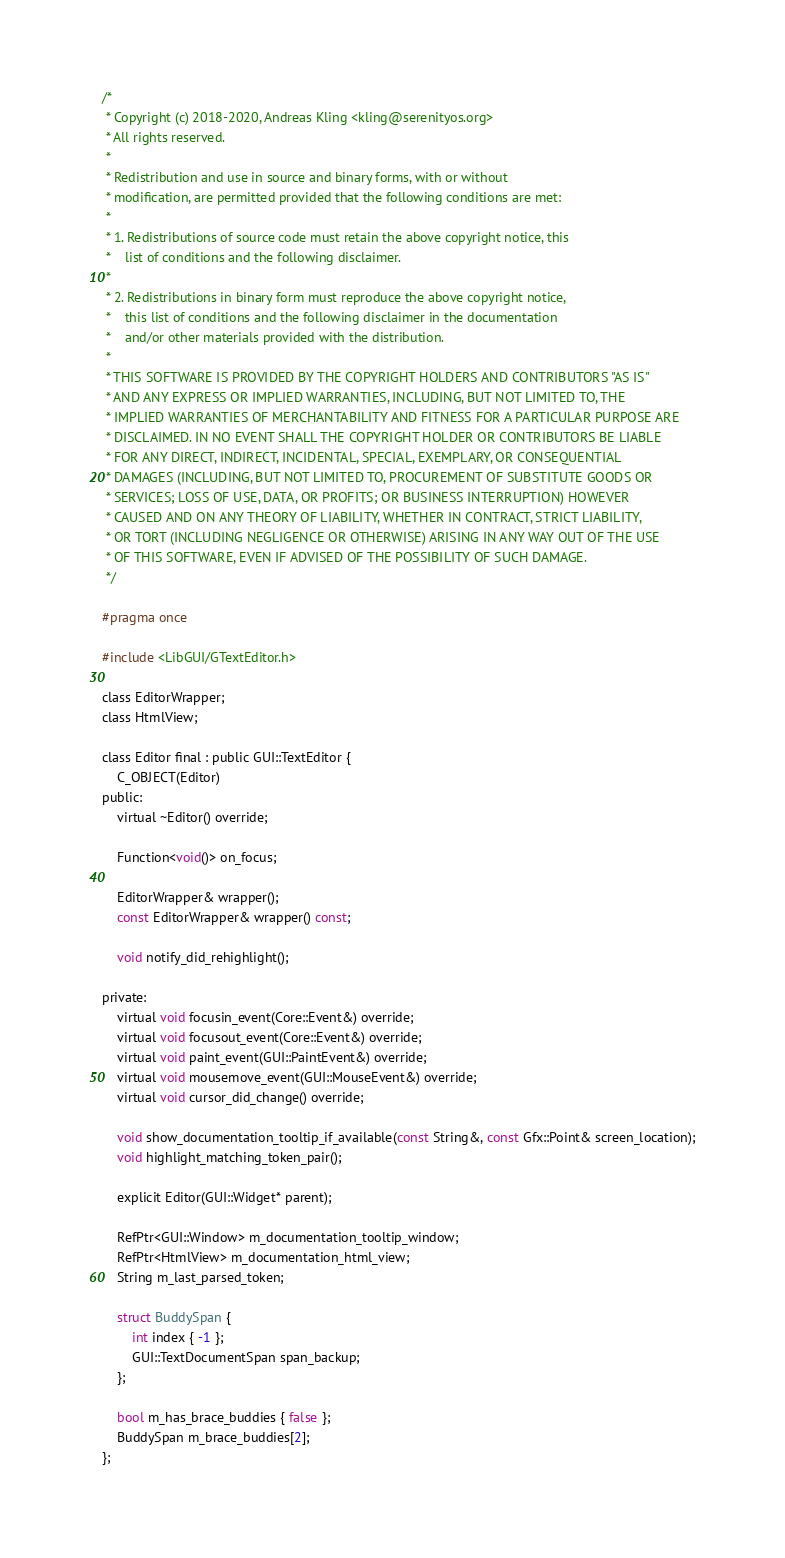Convert code to text. <code><loc_0><loc_0><loc_500><loc_500><_C_>/*
 * Copyright (c) 2018-2020, Andreas Kling <kling@serenityos.org>
 * All rights reserved.
 *
 * Redistribution and use in source and binary forms, with or without
 * modification, are permitted provided that the following conditions are met:
 *
 * 1. Redistributions of source code must retain the above copyright notice, this
 *    list of conditions and the following disclaimer.
 *
 * 2. Redistributions in binary form must reproduce the above copyright notice,
 *    this list of conditions and the following disclaimer in the documentation
 *    and/or other materials provided with the distribution.
 *
 * THIS SOFTWARE IS PROVIDED BY THE COPYRIGHT HOLDERS AND CONTRIBUTORS "AS IS"
 * AND ANY EXPRESS OR IMPLIED WARRANTIES, INCLUDING, BUT NOT LIMITED TO, THE
 * IMPLIED WARRANTIES OF MERCHANTABILITY AND FITNESS FOR A PARTICULAR PURPOSE ARE
 * DISCLAIMED. IN NO EVENT SHALL THE COPYRIGHT HOLDER OR CONTRIBUTORS BE LIABLE
 * FOR ANY DIRECT, INDIRECT, INCIDENTAL, SPECIAL, EXEMPLARY, OR CONSEQUENTIAL
 * DAMAGES (INCLUDING, BUT NOT LIMITED TO, PROCUREMENT OF SUBSTITUTE GOODS OR
 * SERVICES; LOSS OF USE, DATA, OR PROFITS; OR BUSINESS INTERRUPTION) HOWEVER
 * CAUSED AND ON ANY THEORY OF LIABILITY, WHETHER IN CONTRACT, STRICT LIABILITY,
 * OR TORT (INCLUDING NEGLIGENCE OR OTHERWISE) ARISING IN ANY WAY OUT OF THE USE
 * OF THIS SOFTWARE, EVEN IF ADVISED OF THE POSSIBILITY OF SUCH DAMAGE.
 */

#pragma once

#include <LibGUI/GTextEditor.h>

class EditorWrapper;
class HtmlView;

class Editor final : public GUI::TextEditor {
    C_OBJECT(Editor)
public:
    virtual ~Editor() override;

    Function<void()> on_focus;

    EditorWrapper& wrapper();
    const EditorWrapper& wrapper() const;

    void notify_did_rehighlight();

private:
    virtual void focusin_event(Core::Event&) override;
    virtual void focusout_event(Core::Event&) override;
    virtual void paint_event(GUI::PaintEvent&) override;
    virtual void mousemove_event(GUI::MouseEvent&) override;
    virtual void cursor_did_change() override;

    void show_documentation_tooltip_if_available(const String&, const Gfx::Point& screen_location);
    void highlight_matching_token_pair();

    explicit Editor(GUI::Widget* parent);

    RefPtr<GUI::Window> m_documentation_tooltip_window;
    RefPtr<HtmlView> m_documentation_html_view;
    String m_last_parsed_token;

    struct BuddySpan {
        int index { -1 };
        GUI::TextDocumentSpan span_backup;
    };

    bool m_has_brace_buddies { false };
    BuddySpan m_brace_buddies[2];
};
</code> 